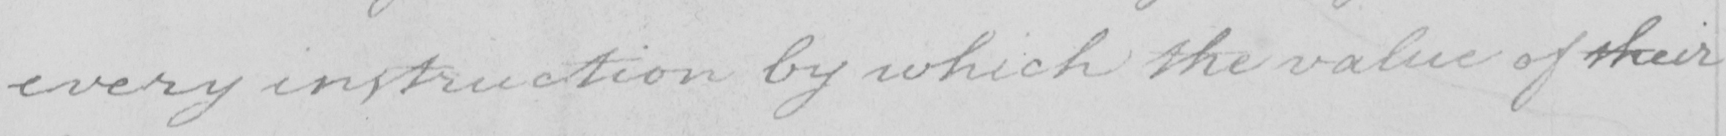What does this handwritten line say? every instruction by which the value of their 